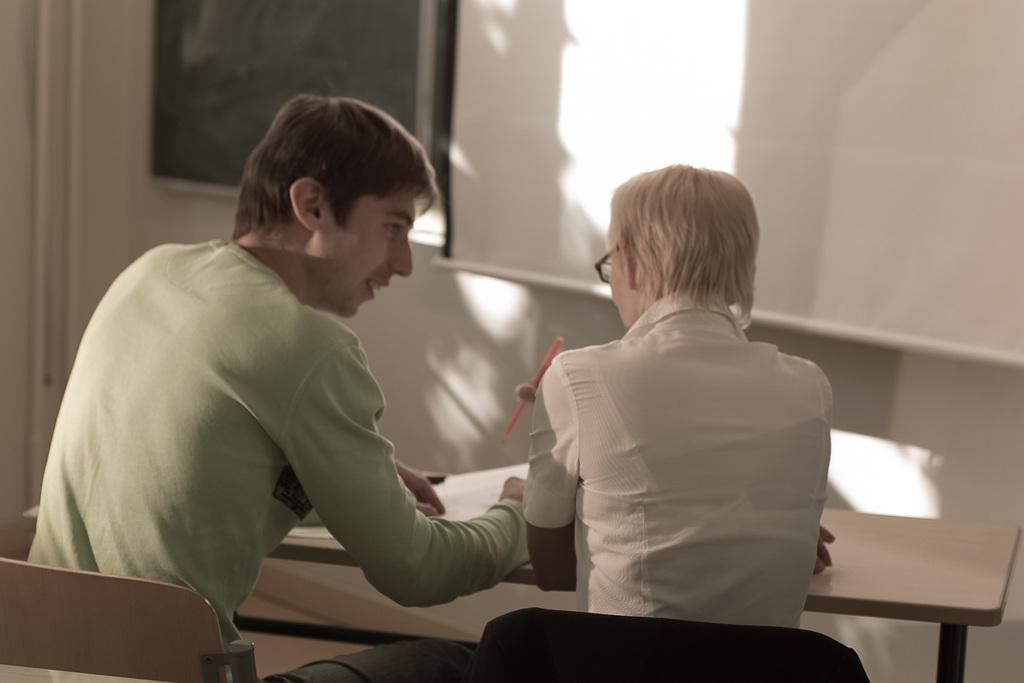In one or two sentences, can you explain what this image depicts? In the image there is a man and woman sat on chair in front of desk and in background there is white board,it seems to be classroom. 